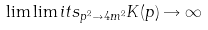<formula> <loc_0><loc_0><loc_500><loc_500>\lim \lim i t s _ { p ^ { 2 } \to 4 m ^ { 2 } } K ( p ) \rightarrow \infty</formula> 